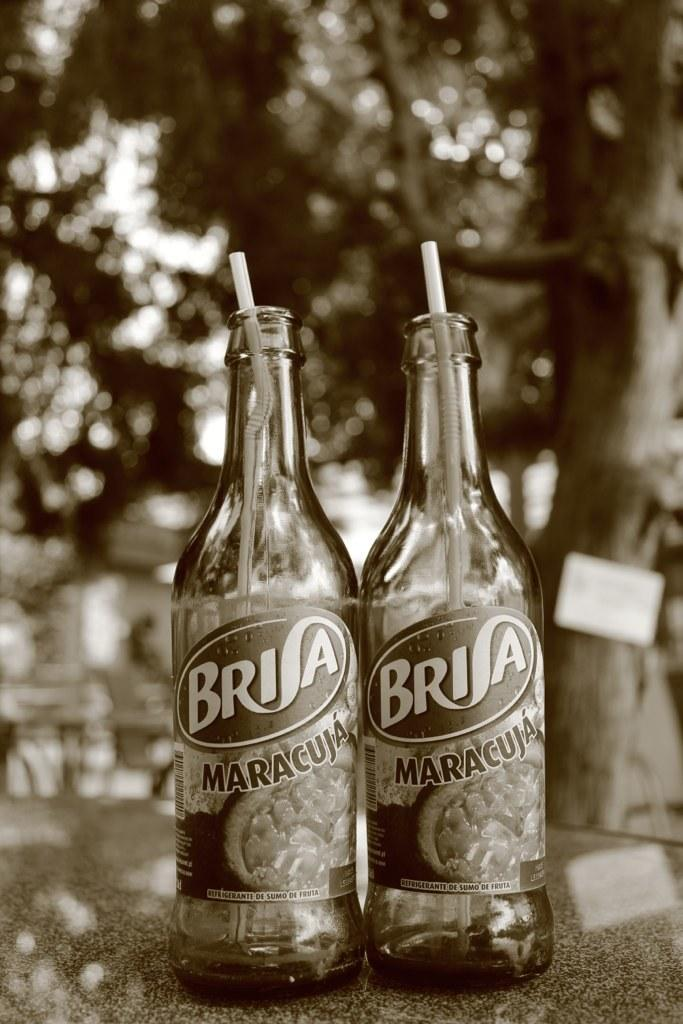<image>
Provide a brief description of the given image. Two bottles with straws in them have the logo for Brisa Maracuja on them. 